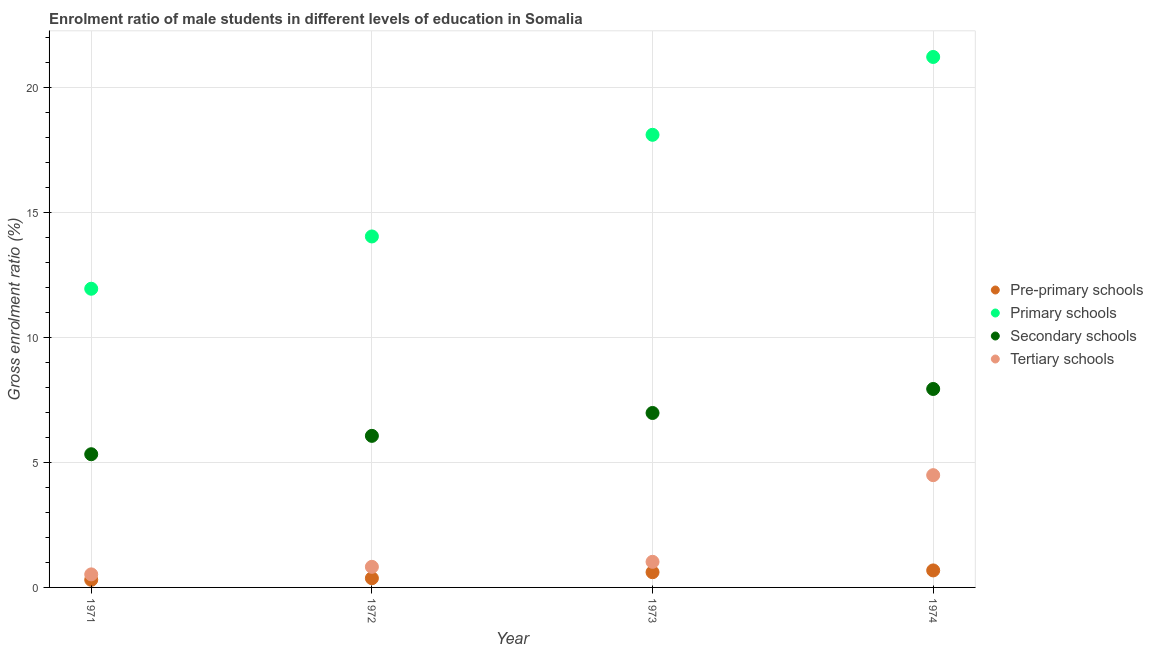Is the number of dotlines equal to the number of legend labels?
Keep it short and to the point. Yes. What is the gross enrolment ratio(female) in pre-primary schools in 1974?
Keep it short and to the point. 0.68. Across all years, what is the maximum gross enrolment ratio(female) in tertiary schools?
Provide a succinct answer. 4.49. Across all years, what is the minimum gross enrolment ratio(female) in tertiary schools?
Your answer should be compact. 0.52. In which year was the gross enrolment ratio(female) in secondary schools maximum?
Your response must be concise. 1974. In which year was the gross enrolment ratio(female) in primary schools minimum?
Make the answer very short. 1971. What is the total gross enrolment ratio(female) in secondary schools in the graph?
Keep it short and to the point. 26.33. What is the difference between the gross enrolment ratio(female) in pre-primary schools in 1971 and that in 1972?
Provide a succinct answer. -0.06. What is the difference between the gross enrolment ratio(female) in primary schools in 1974 and the gross enrolment ratio(female) in secondary schools in 1973?
Your answer should be compact. 14.25. What is the average gross enrolment ratio(female) in tertiary schools per year?
Provide a short and direct response. 1.72. In the year 1972, what is the difference between the gross enrolment ratio(female) in pre-primary schools and gross enrolment ratio(female) in tertiary schools?
Provide a succinct answer. -0.46. In how many years, is the gross enrolment ratio(female) in primary schools greater than 4 %?
Give a very brief answer. 4. What is the ratio of the gross enrolment ratio(female) in primary schools in 1971 to that in 1974?
Ensure brevity in your answer.  0.56. What is the difference between the highest and the second highest gross enrolment ratio(female) in pre-primary schools?
Provide a short and direct response. 0.07. What is the difference between the highest and the lowest gross enrolment ratio(female) in tertiary schools?
Offer a very short reply. 3.97. Is the sum of the gross enrolment ratio(female) in tertiary schools in 1972 and 1973 greater than the maximum gross enrolment ratio(female) in primary schools across all years?
Ensure brevity in your answer.  No. Is it the case that in every year, the sum of the gross enrolment ratio(female) in primary schools and gross enrolment ratio(female) in secondary schools is greater than the sum of gross enrolment ratio(female) in tertiary schools and gross enrolment ratio(female) in pre-primary schools?
Ensure brevity in your answer.  No. Is it the case that in every year, the sum of the gross enrolment ratio(female) in pre-primary schools and gross enrolment ratio(female) in primary schools is greater than the gross enrolment ratio(female) in secondary schools?
Ensure brevity in your answer.  Yes. Is the gross enrolment ratio(female) in pre-primary schools strictly greater than the gross enrolment ratio(female) in secondary schools over the years?
Provide a succinct answer. No. How many dotlines are there?
Your answer should be compact. 4. What is the difference between two consecutive major ticks on the Y-axis?
Your answer should be compact. 5. Are the values on the major ticks of Y-axis written in scientific E-notation?
Your answer should be compact. No. Does the graph contain any zero values?
Your answer should be very brief. No. Does the graph contain grids?
Your answer should be very brief. Yes. Where does the legend appear in the graph?
Offer a terse response. Center right. How many legend labels are there?
Provide a short and direct response. 4. How are the legend labels stacked?
Offer a terse response. Vertical. What is the title of the graph?
Give a very brief answer. Enrolment ratio of male students in different levels of education in Somalia. What is the label or title of the X-axis?
Provide a succinct answer. Year. What is the label or title of the Y-axis?
Ensure brevity in your answer.  Gross enrolment ratio (%). What is the Gross enrolment ratio (%) in Pre-primary schools in 1971?
Your answer should be compact. 0.3. What is the Gross enrolment ratio (%) of Primary schools in 1971?
Your response must be concise. 11.96. What is the Gross enrolment ratio (%) in Secondary schools in 1971?
Your answer should be compact. 5.33. What is the Gross enrolment ratio (%) in Tertiary schools in 1971?
Give a very brief answer. 0.52. What is the Gross enrolment ratio (%) of Pre-primary schools in 1972?
Your answer should be very brief. 0.37. What is the Gross enrolment ratio (%) in Primary schools in 1972?
Your answer should be compact. 14.05. What is the Gross enrolment ratio (%) in Secondary schools in 1972?
Give a very brief answer. 6.07. What is the Gross enrolment ratio (%) in Tertiary schools in 1972?
Provide a succinct answer. 0.82. What is the Gross enrolment ratio (%) in Pre-primary schools in 1973?
Provide a short and direct response. 0.61. What is the Gross enrolment ratio (%) of Primary schools in 1973?
Your answer should be compact. 18.12. What is the Gross enrolment ratio (%) of Secondary schools in 1973?
Your answer should be compact. 6.98. What is the Gross enrolment ratio (%) in Tertiary schools in 1973?
Your answer should be compact. 1.02. What is the Gross enrolment ratio (%) in Pre-primary schools in 1974?
Provide a succinct answer. 0.68. What is the Gross enrolment ratio (%) of Primary schools in 1974?
Ensure brevity in your answer.  21.23. What is the Gross enrolment ratio (%) of Secondary schools in 1974?
Ensure brevity in your answer.  7.94. What is the Gross enrolment ratio (%) in Tertiary schools in 1974?
Give a very brief answer. 4.49. Across all years, what is the maximum Gross enrolment ratio (%) of Pre-primary schools?
Your response must be concise. 0.68. Across all years, what is the maximum Gross enrolment ratio (%) in Primary schools?
Give a very brief answer. 21.23. Across all years, what is the maximum Gross enrolment ratio (%) of Secondary schools?
Your answer should be compact. 7.94. Across all years, what is the maximum Gross enrolment ratio (%) in Tertiary schools?
Offer a very short reply. 4.49. Across all years, what is the minimum Gross enrolment ratio (%) in Pre-primary schools?
Offer a very short reply. 0.3. Across all years, what is the minimum Gross enrolment ratio (%) in Primary schools?
Give a very brief answer. 11.96. Across all years, what is the minimum Gross enrolment ratio (%) of Secondary schools?
Provide a short and direct response. 5.33. Across all years, what is the minimum Gross enrolment ratio (%) in Tertiary schools?
Offer a very short reply. 0.52. What is the total Gross enrolment ratio (%) in Pre-primary schools in the graph?
Your answer should be compact. 1.96. What is the total Gross enrolment ratio (%) in Primary schools in the graph?
Make the answer very short. 65.36. What is the total Gross enrolment ratio (%) of Secondary schools in the graph?
Provide a short and direct response. 26.33. What is the total Gross enrolment ratio (%) in Tertiary schools in the graph?
Your answer should be very brief. 6.86. What is the difference between the Gross enrolment ratio (%) of Pre-primary schools in 1971 and that in 1972?
Offer a terse response. -0.06. What is the difference between the Gross enrolment ratio (%) in Primary schools in 1971 and that in 1972?
Provide a succinct answer. -2.09. What is the difference between the Gross enrolment ratio (%) in Secondary schools in 1971 and that in 1972?
Provide a short and direct response. -0.74. What is the difference between the Gross enrolment ratio (%) in Tertiary schools in 1971 and that in 1972?
Make the answer very short. -0.3. What is the difference between the Gross enrolment ratio (%) of Pre-primary schools in 1971 and that in 1973?
Offer a very short reply. -0.3. What is the difference between the Gross enrolment ratio (%) of Primary schools in 1971 and that in 1973?
Provide a succinct answer. -6.16. What is the difference between the Gross enrolment ratio (%) in Secondary schools in 1971 and that in 1973?
Your response must be concise. -1.65. What is the difference between the Gross enrolment ratio (%) of Tertiary schools in 1971 and that in 1973?
Keep it short and to the point. -0.5. What is the difference between the Gross enrolment ratio (%) of Pre-primary schools in 1971 and that in 1974?
Your response must be concise. -0.38. What is the difference between the Gross enrolment ratio (%) in Primary schools in 1971 and that in 1974?
Make the answer very short. -9.28. What is the difference between the Gross enrolment ratio (%) in Secondary schools in 1971 and that in 1974?
Your answer should be compact. -2.61. What is the difference between the Gross enrolment ratio (%) of Tertiary schools in 1971 and that in 1974?
Provide a succinct answer. -3.97. What is the difference between the Gross enrolment ratio (%) of Pre-primary schools in 1972 and that in 1973?
Your answer should be very brief. -0.24. What is the difference between the Gross enrolment ratio (%) of Primary schools in 1972 and that in 1973?
Ensure brevity in your answer.  -4.07. What is the difference between the Gross enrolment ratio (%) in Secondary schools in 1972 and that in 1973?
Your answer should be very brief. -0.92. What is the difference between the Gross enrolment ratio (%) of Tertiary schools in 1972 and that in 1973?
Your response must be concise. -0.2. What is the difference between the Gross enrolment ratio (%) of Pre-primary schools in 1972 and that in 1974?
Offer a very short reply. -0.31. What is the difference between the Gross enrolment ratio (%) in Primary schools in 1972 and that in 1974?
Provide a short and direct response. -7.18. What is the difference between the Gross enrolment ratio (%) of Secondary schools in 1972 and that in 1974?
Offer a terse response. -1.88. What is the difference between the Gross enrolment ratio (%) of Tertiary schools in 1972 and that in 1974?
Ensure brevity in your answer.  -3.67. What is the difference between the Gross enrolment ratio (%) of Pre-primary schools in 1973 and that in 1974?
Your response must be concise. -0.07. What is the difference between the Gross enrolment ratio (%) in Primary schools in 1973 and that in 1974?
Make the answer very short. -3.12. What is the difference between the Gross enrolment ratio (%) of Secondary schools in 1973 and that in 1974?
Keep it short and to the point. -0.96. What is the difference between the Gross enrolment ratio (%) in Tertiary schools in 1973 and that in 1974?
Provide a short and direct response. -3.47. What is the difference between the Gross enrolment ratio (%) in Pre-primary schools in 1971 and the Gross enrolment ratio (%) in Primary schools in 1972?
Offer a terse response. -13.74. What is the difference between the Gross enrolment ratio (%) in Pre-primary schools in 1971 and the Gross enrolment ratio (%) in Secondary schools in 1972?
Your answer should be compact. -5.76. What is the difference between the Gross enrolment ratio (%) of Pre-primary schools in 1971 and the Gross enrolment ratio (%) of Tertiary schools in 1972?
Your answer should be compact. -0.52. What is the difference between the Gross enrolment ratio (%) in Primary schools in 1971 and the Gross enrolment ratio (%) in Secondary schools in 1972?
Make the answer very short. 5.89. What is the difference between the Gross enrolment ratio (%) of Primary schools in 1971 and the Gross enrolment ratio (%) of Tertiary schools in 1972?
Give a very brief answer. 11.13. What is the difference between the Gross enrolment ratio (%) of Secondary schools in 1971 and the Gross enrolment ratio (%) of Tertiary schools in 1972?
Keep it short and to the point. 4.51. What is the difference between the Gross enrolment ratio (%) of Pre-primary schools in 1971 and the Gross enrolment ratio (%) of Primary schools in 1973?
Your answer should be compact. -17.81. What is the difference between the Gross enrolment ratio (%) of Pre-primary schools in 1971 and the Gross enrolment ratio (%) of Secondary schools in 1973?
Your answer should be very brief. -6.68. What is the difference between the Gross enrolment ratio (%) of Pre-primary schools in 1971 and the Gross enrolment ratio (%) of Tertiary schools in 1973?
Keep it short and to the point. -0.72. What is the difference between the Gross enrolment ratio (%) in Primary schools in 1971 and the Gross enrolment ratio (%) in Secondary schools in 1973?
Give a very brief answer. 4.97. What is the difference between the Gross enrolment ratio (%) of Primary schools in 1971 and the Gross enrolment ratio (%) of Tertiary schools in 1973?
Give a very brief answer. 10.93. What is the difference between the Gross enrolment ratio (%) of Secondary schools in 1971 and the Gross enrolment ratio (%) of Tertiary schools in 1973?
Your answer should be compact. 4.31. What is the difference between the Gross enrolment ratio (%) of Pre-primary schools in 1971 and the Gross enrolment ratio (%) of Primary schools in 1974?
Make the answer very short. -20.93. What is the difference between the Gross enrolment ratio (%) in Pre-primary schools in 1971 and the Gross enrolment ratio (%) in Secondary schools in 1974?
Provide a short and direct response. -7.64. What is the difference between the Gross enrolment ratio (%) of Pre-primary schools in 1971 and the Gross enrolment ratio (%) of Tertiary schools in 1974?
Provide a succinct answer. -4.19. What is the difference between the Gross enrolment ratio (%) in Primary schools in 1971 and the Gross enrolment ratio (%) in Secondary schools in 1974?
Offer a very short reply. 4.01. What is the difference between the Gross enrolment ratio (%) of Primary schools in 1971 and the Gross enrolment ratio (%) of Tertiary schools in 1974?
Provide a short and direct response. 7.46. What is the difference between the Gross enrolment ratio (%) in Secondary schools in 1971 and the Gross enrolment ratio (%) in Tertiary schools in 1974?
Give a very brief answer. 0.84. What is the difference between the Gross enrolment ratio (%) of Pre-primary schools in 1972 and the Gross enrolment ratio (%) of Primary schools in 1973?
Ensure brevity in your answer.  -17.75. What is the difference between the Gross enrolment ratio (%) in Pre-primary schools in 1972 and the Gross enrolment ratio (%) in Secondary schools in 1973?
Give a very brief answer. -6.61. What is the difference between the Gross enrolment ratio (%) of Pre-primary schools in 1972 and the Gross enrolment ratio (%) of Tertiary schools in 1973?
Ensure brevity in your answer.  -0.66. What is the difference between the Gross enrolment ratio (%) in Primary schools in 1972 and the Gross enrolment ratio (%) in Secondary schools in 1973?
Offer a terse response. 7.07. What is the difference between the Gross enrolment ratio (%) of Primary schools in 1972 and the Gross enrolment ratio (%) of Tertiary schools in 1973?
Make the answer very short. 13.02. What is the difference between the Gross enrolment ratio (%) in Secondary schools in 1972 and the Gross enrolment ratio (%) in Tertiary schools in 1973?
Offer a terse response. 5.04. What is the difference between the Gross enrolment ratio (%) of Pre-primary schools in 1972 and the Gross enrolment ratio (%) of Primary schools in 1974?
Your answer should be compact. -20.87. What is the difference between the Gross enrolment ratio (%) of Pre-primary schools in 1972 and the Gross enrolment ratio (%) of Secondary schools in 1974?
Provide a short and direct response. -7.58. What is the difference between the Gross enrolment ratio (%) in Pre-primary schools in 1972 and the Gross enrolment ratio (%) in Tertiary schools in 1974?
Provide a succinct answer. -4.13. What is the difference between the Gross enrolment ratio (%) in Primary schools in 1972 and the Gross enrolment ratio (%) in Secondary schools in 1974?
Your response must be concise. 6.11. What is the difference between the Gross enrolment ratio (%) in Primary schools in 1972 and the Gross enrolment ratio (%) in Tertiary schools in 1974?
Make the answer very short. 9.56. What is the difference between the Gross enrolment ratio (%) in Secondary schools in 1972 and the Gross enrolment ratio (%) in Tertiary schools in 1974?
Provide a short and direct response. 1.57. What is the difference between the Gross enrolment ratio (%) of Pre-primary schools in 1973 and the Gross enrolment ratio (%) of Primary schools in 1974?
Keep it short and to the point. -20.62. What is the difference between the Gross enrolment ratio (%) of Pre-primary schools in 1973 and the Gross enrolment ratio (%) of Secondary schools in 1974?
Keep it short and to the point. -7.33. What is the difference between the Gross enrolment ratio (%) in Pre-primary schools in 1973 and the Gross enrolment ratio (%) in Tertiary schools in 1974?
Give a very brief answer. -3.88. What is the difference between the Gross enrolment ratio (%) of Primary schools in 1973 and the Gross enrolment ratio (%) of Secondary schools in 1974?
Offer a very short reply. 10.17. What is the difference between the Gross enrolment ratio (%) of Primary schools in 1973 and the Gross enrolment ratio (%) of Tertiary schools in 1974?
Offer a very short reply. 13.62. What is the difference between the Gross enrolment ratio (%) of Secondary schools in 1973 and the Gross enrolment ratio (%) of Tertiary schools in 1974?
Keep it short and to the point. 2.49. What is the average Gross enrolment ratio (%) of Pre-primary schools per year?
Provide a succinct answer. 0.49. What is the average Gross enrolment ratio (%) in Primary schools per year?
Ensure brevity in your answer.  16.34. What is the average Gross enrolment ratio (%) in Secondary schools per year?
Keep it short and to the point. 6.58. What is the average Gross enrolment ratio (%) in Tertiary schools per year?
Keep it short and to the point. 1.72. In the year 1971, what is the difference between the Gross enrolment ratio (%) in Pre-primary schools and Gross enrolment ratio (%) in Primary schools?
Your answer should be very brief. -11.65. In the year 1971, what is the difference between the Gross enrolment ratio (%) of Pre-primary schools and Gross enrolment ratio (%) of Secondary schools?
Your response must be concise. -5.03. In the year 1971, what is the difference between the Gross enrolment ratio (%) of Pre-primary schools and Gross enrolment ratio (%) of Tertiary schools?
Keep it short and to the point. -0.22. In the year 1971, what is the difference between the Gross enrolment ratio (%) in Primary schools and Gross enrolment ratio (%) in Secondary schools?
Give a very brief answer. 6.62. In the year 1971, what is the difference between the Gross enrolment ratio (%) of Primary schools and Gross enrolment ratio (%) of Tertiary schools?
Your answer should be very brief. 11.43. In the year 1971, what is the difference between the Gross enrolment ratio (%) in Secondary schools and Gross enrolment ratio (%) in Tertiary schools?
Offer a very short reply. 4.81. In the year 1972, what is the difference between the Gross enrolment ratio (%) in Pre-primary schools and Gross enrolment ratio (%) in Primary schools?
Your answer should be compact. -13.68. In the year 1972, what is the difference between the Gross enrolment ratio (%) of Pre-primary schools and Gross enrolment ratio (%) of Secondary schools?
Your answer should be compact. -5.7. In the year 1972, what is the difference between the Gross enrolment ratio (%) of Pre-primary schools and Gross enrolment ratio (%) of Tertiary schools?
Your response must be concise. -0.46. In the year 1972, what is the difference between the Gross enrolment ratio (%) of Primary schools and Gross enrolment ratio (%) of Secondary schools?
Provide a short and direct response. 7.98. In the year 1972, what is the difference between the Gross enrolment ratio (%) in Primary schools and Gross enrolment ratio (%) in Tertiary schools?
Provide a succinct answer. 13.22. In the year 1972, what is the difference between the Gross enrolment ratio (%) in Secondary schools and Gross enrolment ratio (%) in Tertiary schools?
Keep it short and to the point. 5.24. In the year 1973, what is the difference between the Gross enrolment ratio (%) of Pre-primary schools and Gross enrolment ratio (%) of Primary schools?
Provide a succinct answer. -17.51. In the year 1973, what is the difference between the Gross enrolment ratio (%) in Pre-primary schools and Gross enrolment ratio (%) in Secondary schools?
Provide a short and direct response. -6.37. In the year 1973, what is the difference between the Gross enrolment ratio (%) of Pre-primary schools and Gross enrolment ratio (%) of Tertiary schools?
Offer a very short reply. -0.42. In the year 1973, what is the difference between the Gross enrolment ratio (%) of Primary schools and Gross enrolment ratio (%) of Secondary schools?
Provide a succinct answer. 11.13. In the year 1973, what is the difference between the Gross enrolment ratio (%) of Primary schools and Gross enrolment ratio (%) of Tertiary schools?
Provide a succinct answer. 17.09. In the year 1973, what is the difference between the Gross enrolment ratio (%) of Secondary schools and Gross enrolment ratio (%) of Tertiary schools?
Your answer should be very brief. 5.96. In the year 1974, what is the difference between the Gross enrolment ratio (%) of Pre-primary schools and Gross enrolment ratio (%) of Primary schools?
Your answer should be very brief. -20.55. In the year 1974, what is the difference between the Gross enrolment ratio (%) of Pre-primary schools and Gross enrolment ratio (%) of Secondary schools?
Ensure brevity in your answer.  -7.26. In the year 1974, what is the difference between the Gross enrolment ratio (%) of Pre-primary schools and Gross enrolment ratio (%) of Tertiary schools?
Your response must be concise. -3.81. In the year 1974, what is the difference between the Gross enrolment ratio (%) in Primary schools and Gross enrolment ratio (%) in Secondary schools?
Provide a short and direct response. 13.29. In the year 1974, what is the difference between the Gross enrolment ratio (%) in Primary schools and Gross enrolment ratio (%) in Tertiary schools?
Offer a terse response. 16.74. In the year 1974, what is the difference between the Gross enrolment ratio (%) in Secondary schools and Gross enrolment ratio (%) in Tertiary schools?
Offer a terse response. 3.45. What is the ratio of the Gross enrolment ratio (%) of Pre-primary schools in 1971 to that in 1972?
Your answer should be very brief. 0.83. What is the ratio of the Gross enrolment ratio (%) in Primary schools in 1971 to that in 1972?
Your response must be concise. 0.85. What is the ratio of the Gross enrolment ratio (%) in Secondary schools in 1971 to that in 1972?
Provide a succinct answer. 0.88. What is the ratio of the Gross enrolment ratio (%) in Tertiary schools in 1971 to that in 1972?
Offer a very short reply. 0.63. What is the ratio of the Gross enrolment ratio (%) in Pre-primary schools in 1971 to that in 1973?
Offer a very short reply. 0.5. What is the ratio of the Gross enrolment ratio (%) in Primary schools in 1971 to that in 1973?
Give a very brief answer. 0.66. What is the ratio of the Gross enrolment ratio (%) in Secondary schools in 1971 to that in 1973?
Make the answer very short. 0.76. What is the ratio of the Gross enrolment ratio (%) of Tertiary schools in 1971 to that in 1973?
Provide a short and direct response. 0.51. What is the ratio of the Gross enrolment ratio (%) in Pre-primary schools in 1971 to that in 1974?
Provide a short and direct response. 0.45. What is the ratio of the Gross enrolment ratio (%) of Primary schools in 1971 to that in 1974?
Provide a succinct answer. 0.56. What is the ratio of the Gross enrolment ratio (%) of Secondary schools in 1971 to that in 1974?
Give a very brief answer. 0.67. What is the ratio of the Gross enrolment ratio (%) of Tertiary schools in 1971 to that in 1974?
Keep it short and to the point. 0.12. What is the ratio of the Gross enrolment ratio (%) in Pre-primary schools in 1972 to that in 1973?
Your answer should be compact. 0.6. What is the ratio of the Gross enrolment ratio (%) of Primary schools in 1972 to that in 1973?
Ensure brevity in your answer.  0.78. What is the ratio of the Gross enrolment ratio (%) of Secondary schools in 1972 to that in 1973?
Your response must be concise. 0.87. What is the ratio of the Gross enrolment ratio (%) in Tertiary schools in 1972 to that in 1973?
Keep it short and to the point. 0.8. What is the ratio of the Gross enrolment ratio (%) in Pre-primary schools in 1972 to that in 1974?
Offer a very short reply. 0.54. What is the ratio of the Gross enrolment ratio (%) in Primary schools in 1972 to that in 1974?
Provide a short and direct response. 0.66. What is the ratio of the Gross enrolment ratio (%) in Secondary schools in 1972 to that in 1974?
Keep it short and to the point. 0.76. What is the ratio of the Gross enrolment ratio (%) in Tertiary schools in 1972 to that in 1974?
Offer a very short reply. 0.18. What is the ratio of the Gross enrolment ratio (%) in Pre-primary schools in 1973 to that in 1974?
Provide a short and direct response. 0.9. What is the ratio of the Gross enrolment ratio (%) of Primary schools in 1973 to that in 1974?
Offer a very short reply. 0.85. What is the ratio of the Gross enrolment ratio (%) in Secondary schools in 1973 to that in 1974?
Your answer should be compact. 0.88. What is the ratio of the Gross enrolment ratio (%) of Tertiary schools in 1973 to that in 1974?
Your answer should be very brief. 0.23. What is the difference between the highest and the second highest Gross enrolment ratio (%) of Pre-primary schools?
Make the answer very short. 0.07. What is the difference between the highest and the second highest Gross enrolment ratio (%) of Primary schools?
Offer a very short reply. 3.12. What is the difference between the highest and the second highest Gross enrolment ratio (%) in Tertiary schools?
Offer a terse response. 3.47. What is the difference between the highest and the lowest Gross enrolment ratio (%) of Pre-primary schools?
Give a very brief answer. 0.38. What is the difference between the highest and the lowest Gross enrolment ratio (%) in Primary schools?
Ensure brevity in your answer.  9.28. What is the difference between the highest and the lowest Gross enrolment ratio (%) in Secondary schools?
Provide a succinct answer. 2.61. What is the difference between the highest and the lowest Gross enrolment ratio (%) of Tertiary schools?
Your response must be concise. 3.97. 